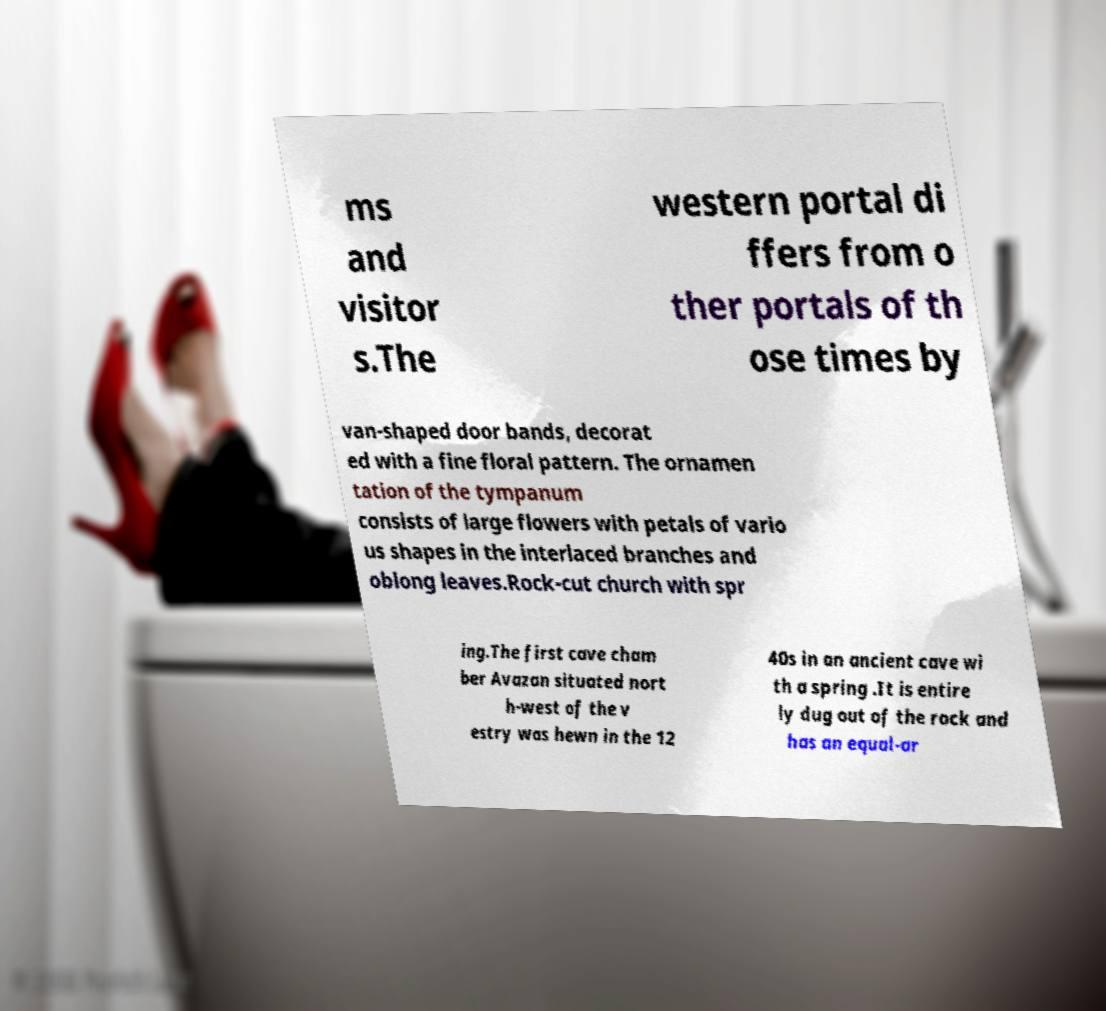Can you accurately transcribe the text from the provided image for me? ms and visitor s.The western portal di ffers from o ther portals of th ose times by van-shaped door bands, decorat ed with a fine floral pattern. The ornamen tation of the tympanum consists of large flowers with petals of vario us shapes in the interlaced branches and oblong leaves.Rock-cut church with spr ing.The first cave cham ber Avazan situated nort h-west of the v estry was hewn in the 12 40s in an ancient cave wi th a spring .It is entire ly dug out of the rock and has an equal-ar 